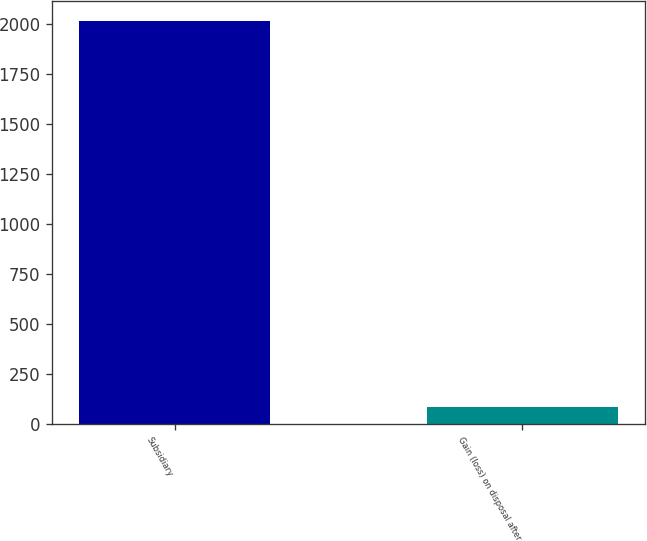Convert chart to OTSL. <chart><loc_0><loc_0><loc_500><loc_500><bar_chart><fcel>Subsidiary<fcel>Gain (loss) on disposal after<nl><fcel>2011<fcel>86<nl></chart> 